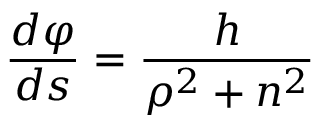<formula> <loc_0><loc_0><loc_500><loc_500>{ \frac { d \varphi } { d s } } = { \frac { h } { \rho ^ { 2 } + n ^ { 2 } } }</formula> 